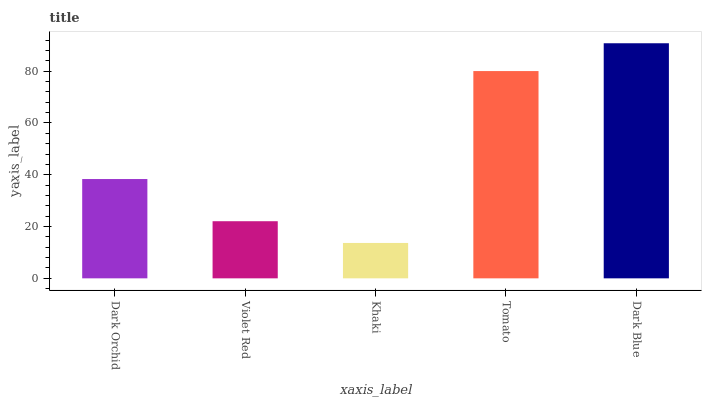Is Khaki the minimum?
Answer yes or no. Yes. Is Dark Blue the maximum?
Answer yes or no. Yes. Is Violet Red the minimum?
Answer yes or no. No. Is Violet Red the maximum?
Answer yes or no. No. Is Dark Orchid greater than Violet Red?
Answer yes or no. Yes. Is Violet Red less than Dark Orchid?
Answer yes or no. Yes. Is Violet Red greater than Dark Orchid?
Answer yes or no. No. Is Dark Orchid less than Violet Red?
Answer yes or no. No. Is Dark Orchid the high median?
Answer yes or no. Yes. Is Dark Orchid the low median?
Answer yes or no. Yes. Is Violet Red the high median?
Answer yes or no. No. Is Dark Blue the low median?
Answer yes or no. No. 